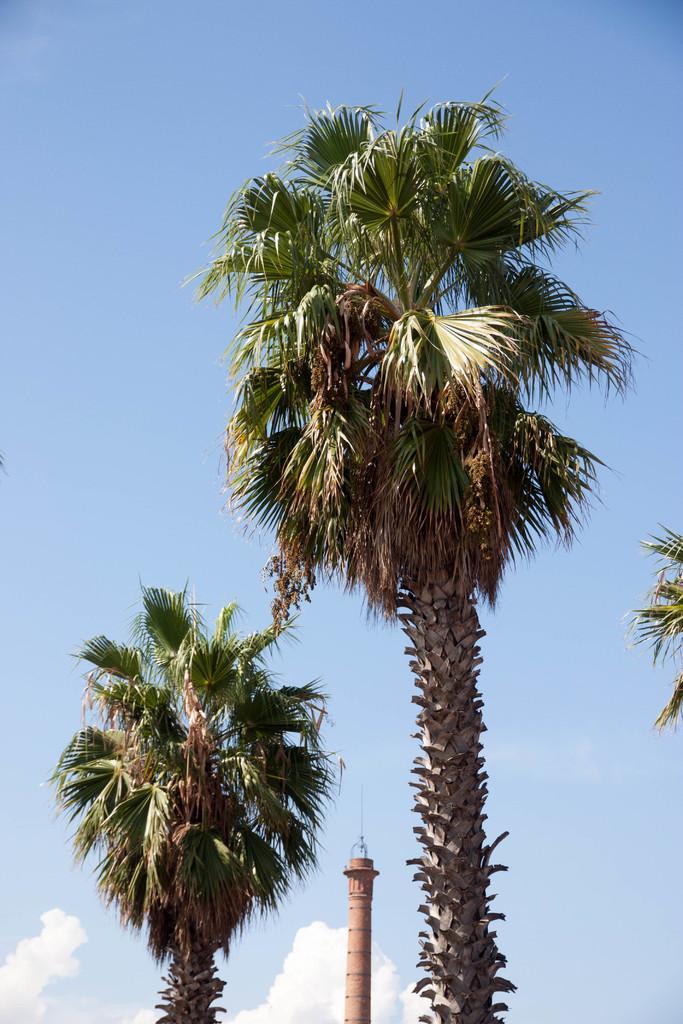Please provide a concise description of this image. In the front of the image I can see trees and tower. In the background of the image I can see blue sky and clouds. 